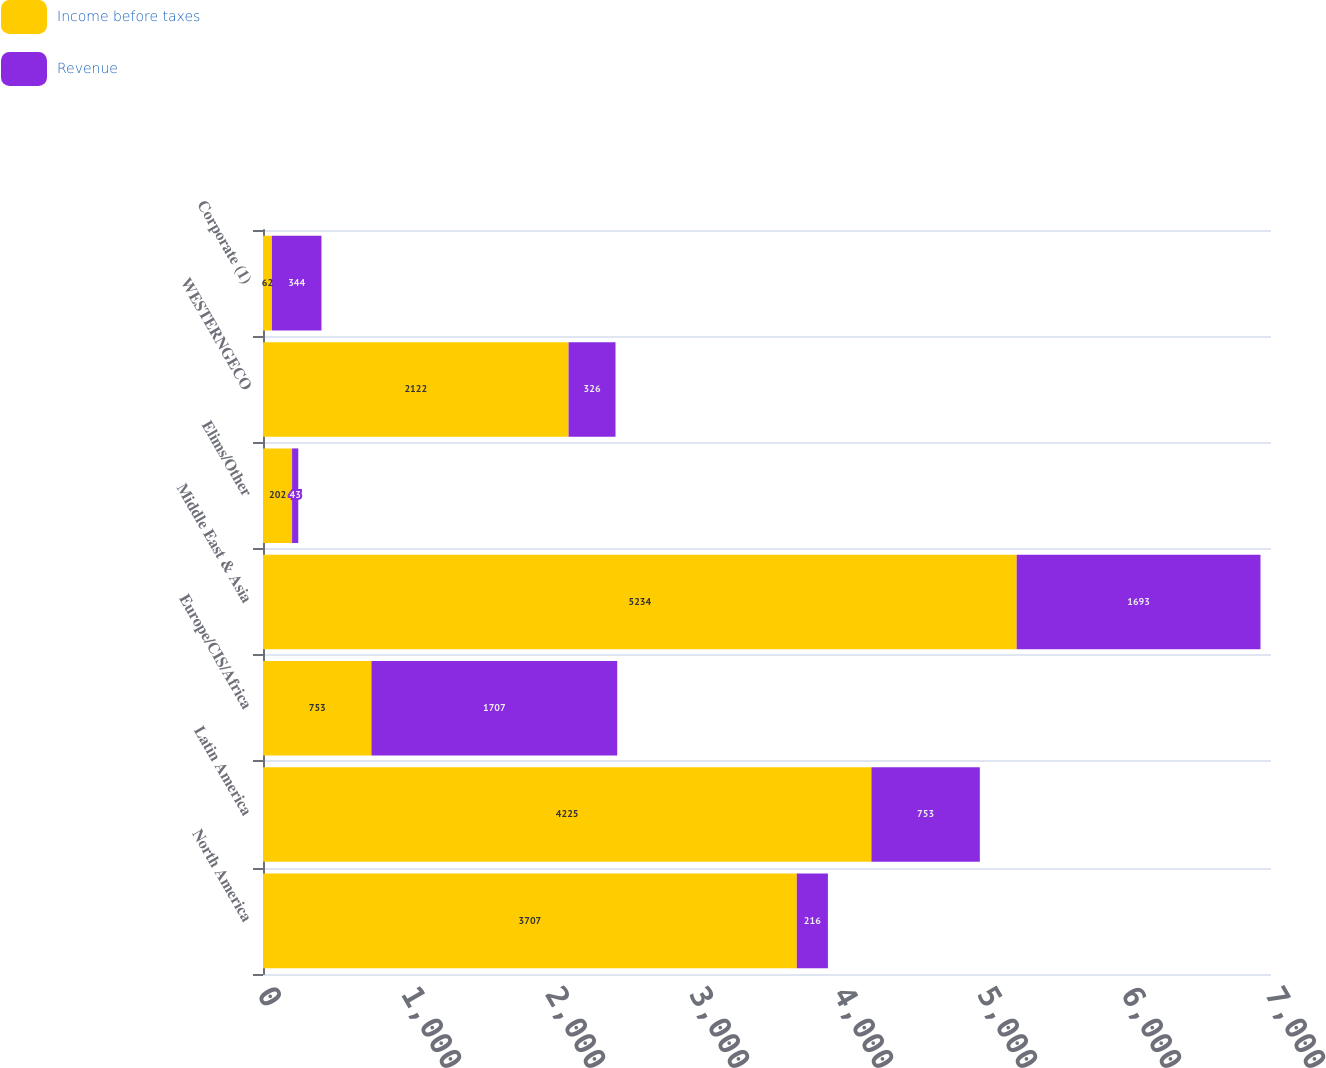<chart> <loc_0><loc_0><loc_500><loc_500><stacked_bar_chart><ecel><fcel>North America<fcel>Latin America<fcel>Europe/CIS/Africa<fcel>Middle East & Asia<fcel>Elims/Other<fcel>WESTERNGECO<fcel>Corporate (1)<nl><fcel>Income before taxes<fcel>3707<fcel>4225<fcel>753<fcel>5234<fcel>202<fcel>2122<fcel>62<nl><fcel>Revenue<fcel>216<fcel>753<fcel>1707<fcel>1693<fcel>43<fcel>326<fcel>344<nl></chart> 